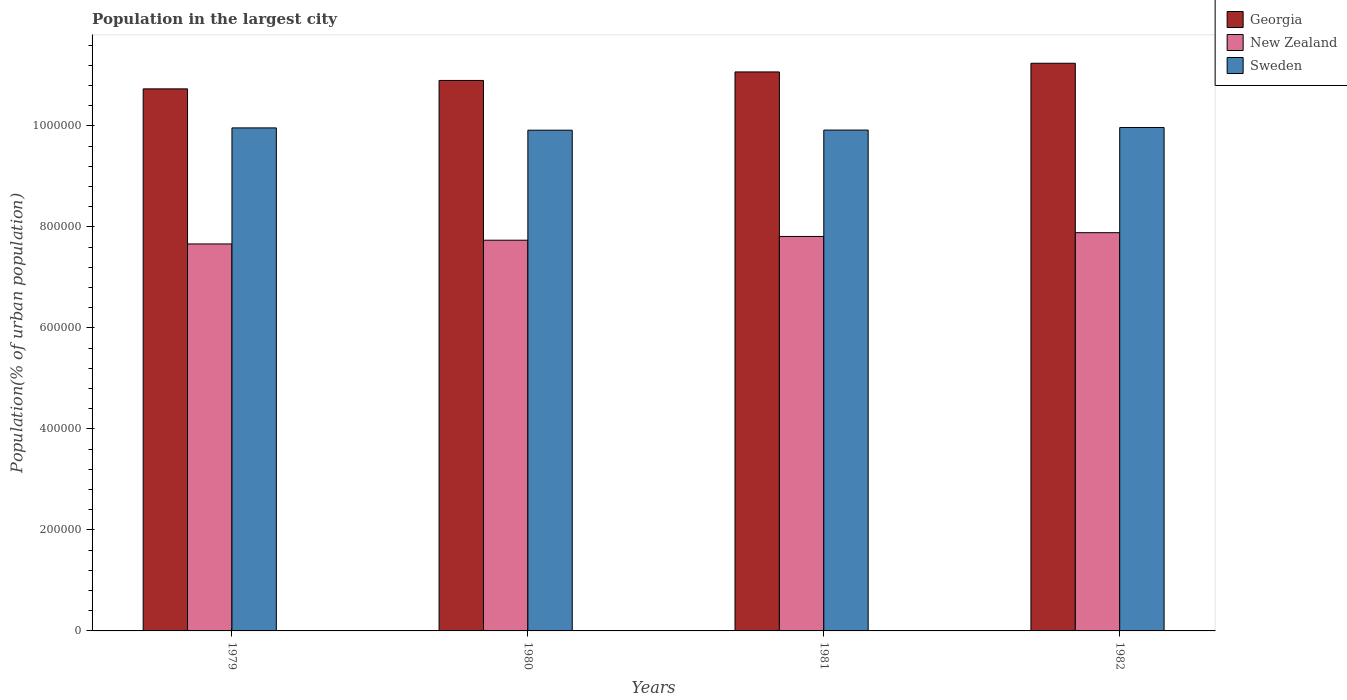How many different coloured bars are there?
Make the answer very short. 3. How many bars are there on the 4th tick from the left?
Provide a succinct answer. 3. How many bars are there on the 4th tick from the right?
Ensure brevity in your answer.  3. What is the label of the 1st group of bars from the left?
Your answer should be compact. 1979. In how many cases, is the number of bars for a given year not equal to the number of legend labels?
Ensure brevity in your answer.  0. What is the population in the largest city in Sweden in 1982?
Offer a very short reply. 9.97e+05. Across all years, what is the maximum population in the largest city in Georgia?
Your answer should be very brief. 1.12e+06. Across all years, what is the minimum population in the largest city in Sweden?
Give a very brief answer. 9.92e+05. In which year was the population in the largest city in Georgia maximum?
Ensure brevity in your answer.  1982. What is the total population in the largest city in New Zealand in the graph?
Offer a terse response. 3.11e+06. What is the difference between the population in the largest city in New Zealand in 1981 and that in 1982?
Give a very brief answer. -7509. What is the difference between the population in the largest city in Georgia in 1982 and the population in the largest city in New Zealand in 1979?
Ensure brevity in your answer.  3.58e+05. What is the average population in the largest city in Georgia per year?
Your answer should be compact. 1.10e+06. In the year 1979, what is the difference between the population in the largest city in Georgia and population in the largest city in New Zealand?
Offer a very short reply. 3.07e+05. In how many years, is the population in the largest city in Sweden greater than 1000000 %?
Give a very brief answer. 0. What is the ratio of the population in the largest city in New Zealand in 1979 to that in 1982?
Your response must be concise. 0.97. Is the population in the largest city in New Zealand in 1979 less than that in 1981?
Ensure brevity in your answer.  Yes. Is the difference between the population in the largest city in Georgia in 1980 and 1981 greater than the difference between the population in the largest city in New Zealand in 1980 and 1981?
Your answer should be compact. No. What is the difference between the highest and the second highest population in the largest city in Sweden?
Your answer should be very brief. 757. What is the difference between the highest and the lowest population in the largest city in Sweden?
Offer a terse response. 5293. In how many years, is the population in the largest city in Sweden greater than the average population in the largest city in Sweden taken over all years?
Your answer should be very brief. 2. What does the 2nd bar from the right in 1980 represents?
Your answer should be very brief. New Zealand. Is it the case that in every year, the sum of the population in the largest city in Sweden and population in the largest city in Georgia is greater than the population in the largest city in New Zealand?
Make the answer very short. Yes. How many bars are there?
Provide a short and direct response. 12. How many years are there in the graph?
Provide a short and direct response. 4. What is the difference between two consecutive major ticks on the Y-axis?
Your answer should be very brief. 2.00e+05. How many legend labels are there?
Offer a terse response. 3. How are the legend labels stacked?
Offer a terse response. Vertical. What is the title of the graph?
Keep it short and to the point. Population in the largest city. Does "Other small states" appear as one of the legend labels in the graph?
Ensure brevity in your answer.  No. What is the label or title of the X-axis?
Ensure brevity in your answer.  Years. What is the label or title of the Y-axis?
Ensure brevity in your answer.  Population(% of urban population). What is the Population(% of urban population) of Georgia in 1979?
Make the answer very short. 1.07e+06. What is the Population(% of urban population) of New Zealand in 1979?
Offer a very short reply. 7.66e+05. What is the Population(% of urban population) in Sweden in 1979?
Provide a succinct answer. 9.96e+05. What is the Population(% of urban population) in Georgia in 1980?
Provide a succinct answer. 1.09e+06. What is the Population(% of urban population) of New Zealand in 1980?
Your response must be concise. 7.74e+05. What is the Population(% of urban population) of Sweden in 1980?
Ensure brevity in your answer.  9.92e+05. What is the Population(% of urban population) in Georgia in 1981?
Make the answer very short. 1.11e+06. What is the Population(% of urban population) in New Zealand in 1981?
Make the answer very short. 7.81e+05. What is the Population(% of urban population) in Sweden in 1981?
Ensure brevity in your answer.  9.92e+05. What is the Population(% of urban population) of Georgia in 1982?
Give a very brief answer. 1.12e+06. What is the Population(% of urban population) in New Zealand in 1982?
Make the answer very short. 7.89e+05. What is the Population(% of urban population) of Sweden in 1982?
Make the answer very short. 9.97e+05. Across all years, what is the maximum Population(% of urban population) in Georgia?
Give a very brief answer. 1.12e+06. Across all years, what is the maximum Population(% of urban population) in New Zealand?
Your response must be concise. 7.89e+05. Across all years, what is the maximum Population(% of urban population) in Sweden?
Offer a terse response. 9.97e+05. Across all years, what is the minimum Population(% of urban population) in Georgia?
Provide a short and direct response. 1.07e+06. Across all years, what is the minimum Population(% of urban population) of New Zealand?
Provide a succinct answer. 7.66e+05. Across all years, what is the minimum Population(% of urban population) in Sweden?
Keep it short and to the point. 9.92e+05. What is the total Population(% of urban population) in Georgia in the graph?
Your answer should be compact. 4.40e+06. What is the total Population(% of urban population) of New Zealand in the graph?
Offer a very short reply. 3.11e+06. What is the total Population(% of urban population) of Sweden in the graph?
Provide a succinct answer. 3.98e+06. What is the difference between the Population(% of urban population) in Georgia in 1979 and that in 1980?
Ensure brevity in your answer.  -1.67e+04. What is the difference between the Population(% of urban population) of New Zealand in 1979 and that in 1980?
Your response must be concise. -7377. What is the difference between the Population(% of urban population) in Sweden in 1979 and that in 1980?
Your response must be concise. 4536. What is the difference between the Population(% of urban population) of Georgia in 1979 and that in 1981?
Give a very brief answer. -3.35e+04. What is the difference between the Population(% of urban population) of New Zealand in 1979 and that in 1981?
Offer a very short reply. -1.48e+04. What is the difference between the Population(% of urban population) of Sweden in 1979 and that in 1981?
Your answer should be very brief. 4287. What is the difference between the Population(% of urban population) of Georgia in 1979 and that in 1982?
Make the answer very short. -5.07e+04. What is the difference between the Population(% of urban population) in New Zealand in 1979 and that in 1982?
Offer a very short reply. -2.23e+04. What is the difference between the Population(% of urban population) of Sweden in 1979 and that in 1982?
Give a very brief answer. -757. What is the difference between the Population(% of urban population) of Georgia in 1980 and that in 1981?
Offer a very short reply. -1.69e+04. What is the difference between the Population(% of urban population) in New Zealand in 1980 and that in 1981?
Keep it short and to the point. -7427. What is the difference between the Population(% of urban population) of Sweden in 1980 and that in 1981?
Make the answer very short. -249. What is the difference between the Population(% of urban population) of Georgia in 1980 and that in 1982?
Keep it short and to the point. -3.40e+04. What is the difference between the Population(% of urban population) in New Zealand in 1980 and that in 1982?
Keep it short and to the point. -1.49e+04. What is the difference between the Population(% of urban population) of Sweden in 1980 and that in 1982?
Your response must be concise. -5293. What is the difference between the Population(% of urban population) in Georgia in 1981 and that in 1982?
Keep it short and to the point. -1.72e+04. What is the difference between the Population(% of urban population) in New Zealand in 1981 and that in 1982?
Offer a very short reply. -7509. What is the difference between the Population(% of urban population) in Sweden in 1981 and that in 1982?
Your answer should be compact. -5044. What is the difference between the Population(% of urban population) in Georgia in 1979 and the Population(% of urban population) in New Zealand in 1980?
Provide a succinct answer. 3.00e+05. What is the difference between the Population(% of urban population) of Georgia in 1979 and the Population(% of urban population) of Sweden in 1980?
Offer a very short reply. 8.18e+04. What is the difference between the Population(% of urban population) in New Zealand in 1979 and the Population(% of urban population) in Sweden in 1980?
Provide a short and direct response. -2.25e+05. What is the difference between the Population(% of urban population) in Georgia in 1979 and the Population(% of urban population) in New Zealand in 1981?
Give a very brief answer. 2.92e+05. What is the difference between the Population(% of urban population) of Georgia in 1979 and the Population(% of urban population) of Sweden in 1981?
Provide a short and direct response. 8.16e+04. What is the difference between the Population(% of urban population) in New Zealand in 1979 and the Population(% of urban population) in Sweden in 1981?
Ensure brevity in your answer.  -2.26e+05. What is the difference between the Population(% of urban population) in Georgia in 1979 and the Population(% of urban population) in New Zealand in 1982?
Provide a succinct answer. 2.85e+05. What is the difference between the Population(% of urban population) in Georgia in 1979 and the Population(% of urban population) in Sweden in 1982?
Your answer should be compact. 7.66e+04. What is the difference between the Population(% of urban population) in New Zealand in 1979 and the Population(% of urban population) in Sweden in 1982?
Your answer should be compact. -2.31e+05. What is the difference between the Population(% of urban population) of Georgia in 1980 and the Population(% of urban population) of New Zealand in 1981?
Provide a succinct answer. 3.09e+05. What is the difference between the Population(% of urban population) in Georgia in 1980 and the Population(% of urban population) in Sweden in 1981?
Offer a terse response. 9.83e+04. What is the difference between the Population(% of urban population) in New Zealand in 1980 and the Population(% of urban population) in Sweden in 1981?
Your response must be concise. -2.18e+05. What is the difference between the Population(% of urban population) of Georgia in 1980 and the Population(% of urban population) of New Zealand in 1982?
Offer a very short reply. 3.01e+05. What is the difference between the Population(% of urban population) of Georgia in 1980 and the Population(% of urban population) of Sweden in 1982?
Your response must be concise. 9.32e+04. What is the difference between the Population(% of urban population) in New Zealand in 1980 and the Population(% of urban population) in Sweden in 1982?
Provide a succinct answer. -2.23e+05. What is the difference between the Population(% of urban population) of Georgia in 1981 and the Population(% of urban population) of New Zealand in 1982?
Your answer should be compact. 3.18e+05. What is the difference between the Population(% of urban population) of Georgia in 1981 and the Population(% of urban population) of Sweden in 1982?
Provide a succinct answer. 1.10e+05. What is the difference between the Population(% of urban population) of New Zealand in 1981 and the Population(% of urban population) of Sweden in 1982?
Give a very brief answer. -2.16e+05. What is the average Population(% of urban population) in Georgia per year?
Make the answer very short. 1.10e+06. What is the average Population(% of urban population) of New Zealand per year?
Provide a succinct answer. 7.78e+05. What is the average Population(% of urban population) of Sweden per year?
Make the answer very short. 9.94e+05. In the year 1979, what is the difference between the Population(% of urban population) in Georgia and Population(% of urban population) in New Zealand?
Your answer should be compact. 3.07e+05. In the year 1979, what is the difference between the Population(% of urban population) of Georgia and Population(% of urban population) of Sweden?
Your response must be concise. 7.73e+04. In the year 1979, what is the difference between the Population(% of urban population) in New Zealand and Population(% of urban population) in Sweden?
Your answer should be very brief. -2.30e+05. In the year 1980, what is the difference between the Population(% of urban population) of Georgia and Population(% of urban population) of New Zealand?
Offer a terse response. 3.16e+05. In the year 1980, what is the difference between the Population(% of urban population) of Georgia and Population(% of urban population) of Sweden?
Give a very brief answer. 9.85e+04. In the year 1980, what is the difference between the Population(% of urban population) of New Zealand and Population(% of urban population) of Sweden?
Provide a short and direct response. -2.18e+05. In the year 1981, what is the difference between the Population(% of urban population) in Georgia and Population(% of urban population) in New Zealand?
Provide a short and direct response. 3.26e+05. In the year 1981, what is the difference between the Population(% of urban population) of Georgia and Population(% of urban population) of Sweden?
Provide a succinct answer. 1.15e+05. In the year 1981, what is the difference between the Population(% of urban population) of New Zealand and Population(% of urban population) of Sweden?
Make the answer very short. -2.11e+05. In the year 1982, what is the difference between the Population(% of urban population) in Georgia and Population(% of urban population) in New Zealand?
Give a very brief answer. 3.36e+05. In the year 1982, what is the difference between the Population(% of urban population) in Georgia and Population(% of urban population) in Sweden?
Give a very brief answer. 1.27e+05. In the year 1982, what is the difference between the Population(% of urban population) of New Zealand and Population(% of urban population) of Sweden?
Make the answer very short. -2.08e+05. What is the ratio of the Population(% of urban population) of Georgia in 1979 to that in 1980?
Offer a terse response. 0.98. What is the ratio of the Population(% of urban population) in Sweden in 1979 to that in 1980?
Ensure brevity in your answer.  1. What is the ratio of the Population(% of urban population) of Georgia in 1979 to that in 1981?
Offer a terse response. 0.97. What is the ratio of the Population(% of urban population) of New Zealand in 1979 to that in 1981?
Offer a very short reply. 0.98. What is the ratio of the Population(% of urban population) of Georgia in 1979 to that in 1982?
Make the answer very short. 0.95. What is the ratio of the Population(% of urban population) in New Zealand in 1979 to that in 1982?
Make the answer very short. 0.97. What is the ratio of the Population(% of urban population) in New Zealand in 1980 to that in 1981?
Give a very brief answer. 0.99. What is the ratio of the Population(% of urban population) in Sweden in 1980 to that in 1981?
Provide a short and direct response. 1. What is the ratio of the Population(% of urban population) in Georgia in 1980 to that in 1982?
Provide a short and direct response. 0.97. What is the ratio of the Population(% of urban population) of New Zealand in 1980 to that in 1982?
Your response must be concise. 0.98. What is the ratio of the Population(% of urban population) in Georgia in 1981 to that in 1982?
Your answer should be very brief. 0.98. What is the ratio of the Population(% of urban population) in Sweden in 1981 to that in 1982?
Make the answer very short. 0.99. What is the difference between the highest and the second highest Population(% of urban population) of Georgia?
Provide a succinct answer. 1.72e+04. What is the difference between the highest and the second highest Population(% of urban population) of New Zealand?
Your answer should be very brief. 7509. What is the difference between the highest and the second highest Population(% of urban population) in Sweden?
Give a very brief answer. 757. What is the difference between the highest and the lowest Population(% of urban population) in Georgia?
Give a very brief answer. 5.07e+04. What is the difference between the highest and the lowest Population(% of urban population) in New Zealand?
Offer a terse response. 2.23e+04. What is the difference between the highest and the lowest Population(% of urban population) of Sweden?
Provide a succinct answer. 5293. 